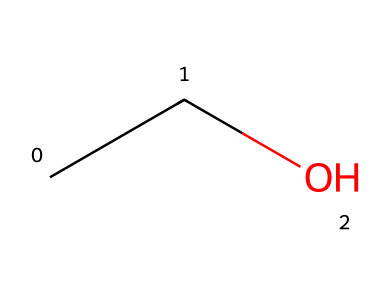What is the name of the chemical represented by this SMILES? The SMILES "CCO" corresponds to the linear structure, which indicates it has two carbon atoms connected to a hydroxyl group (OH). This structure is recognized as ethanol.
Answer: ethanol How many carbon atoms are present in this molecule? The SMILES "CCO" shows two carbon atoms (C) as indicated by the two 'C's at the beginning of the string.
Answer: 2 What type of functional group is present in this molecule? The hydroxyl group (–OH) is clearly visible in the structure, which classifies this molecule as an alcohol.
Answer: alcohol How many hydrogen atoms are in this molecule? The SMILES notation indicates two carbon atoms and an –OH group. Ethanol has the general formula C2H5OH, indicating it contains six hydrogen atoms total.
Answer: 6 Does this molecule exhibit branched or linear structure? The SMILES indicates that the carbon atoms are connected in a straight line without any branches, typical of a linear structure.
Answer: linear What is the main use of this chemical in hand sanitizers? Ethanol is used in hand sanitizers primarily for its efficacy as an antimicrobial agent, effectively neutralizing pathogens.
Answer: antimicrobial agent Is this molecule classified as a saturated or unsaturated hydrocarbon? Ethanol does not contain double or triple bonds between carbon atoms (only single bonds), making it a saturated hydrocarbon.
Answer: saturated 